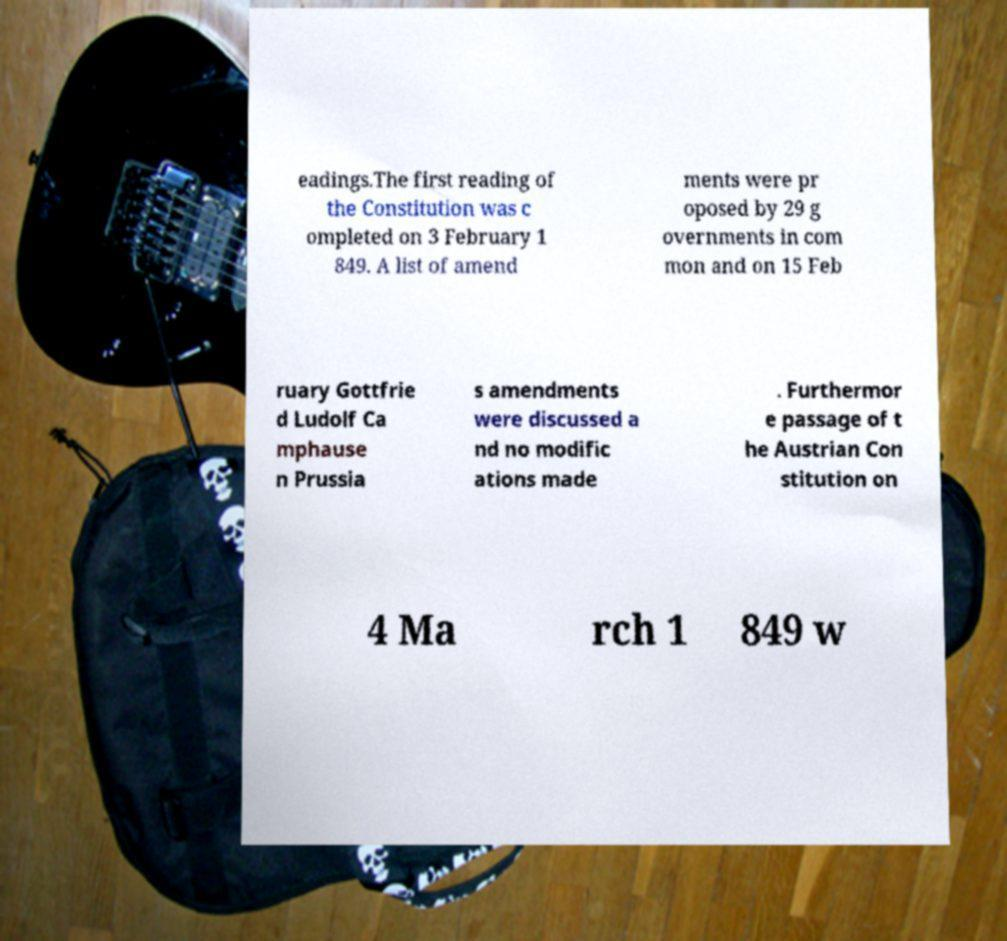Please read and relay the text visible in this image. What does it say? eadings.The first reading of the Constitution was c ompleted on 3 February 1 849. A list of amend ments were pr oposed by 29 g overnments in com mon and on 15 Feb ruary Gottfrie d Ludolf Ca mphause n Prussia s amendments were discussed a nd no modific ations made . Furthermor e passage of t he Austrian Con stitution on 4 Ma rch 1 849 w 